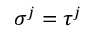<formula> <loc_0><loc_0><loc_500><loc_500>\sigma ^ { j } = \tau ^ { j }</formula> 